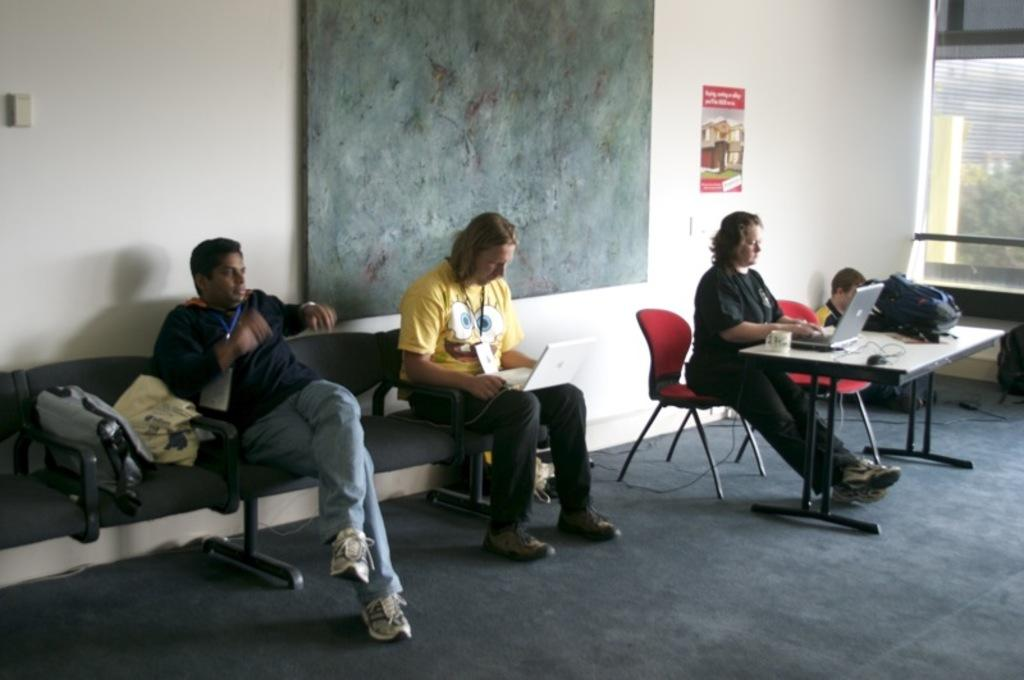How many people are sitting on chairs in the image? There are three people sitting on chairs in the image. What electronic device is on the table? There is a laptop on the table. What other objects are on the table? There is a cup and a bag on the table. Where is the man sitting in the image? The man is sitting on the ground. What type of floor covering is visible in the image? There is a carpet in the image. What is hanging on the wall? There is a poster on the wall. What type of liquid is being poured from the cup in the image? There is no liquid being poured from the cup in the image; it is simply sitting on the table. What type of love is being expressed by the people in the image? There is no indication of love being expressed in the image; it is a neutral scene with people sitting and a laptop on the table. 